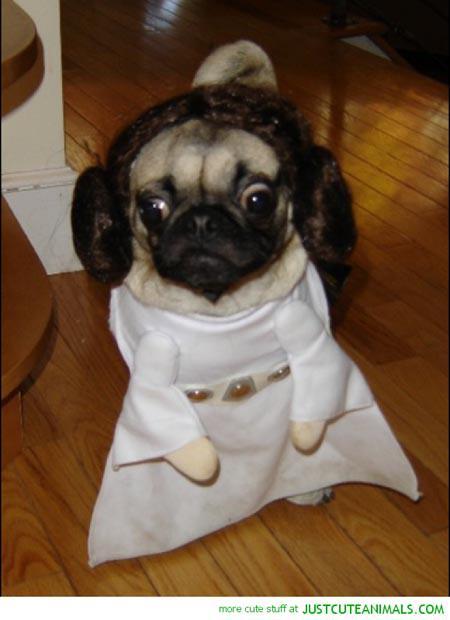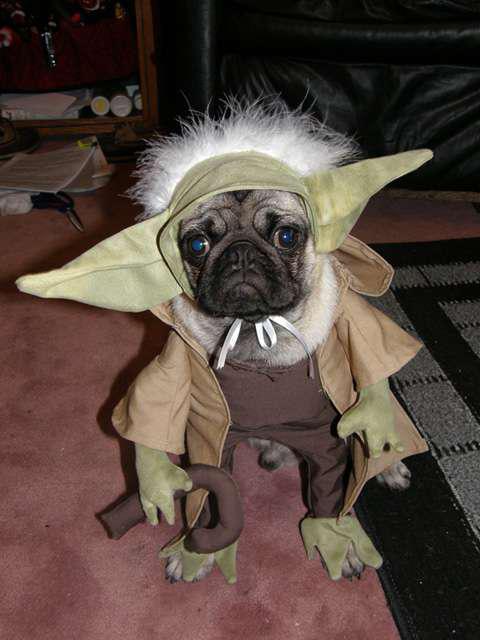The first image is the image on the left, the second image is the image on the right. For the images shown, is this caption "One of the dogs shown is wearing a hat with a brim." true? Answer yes or no. No. 